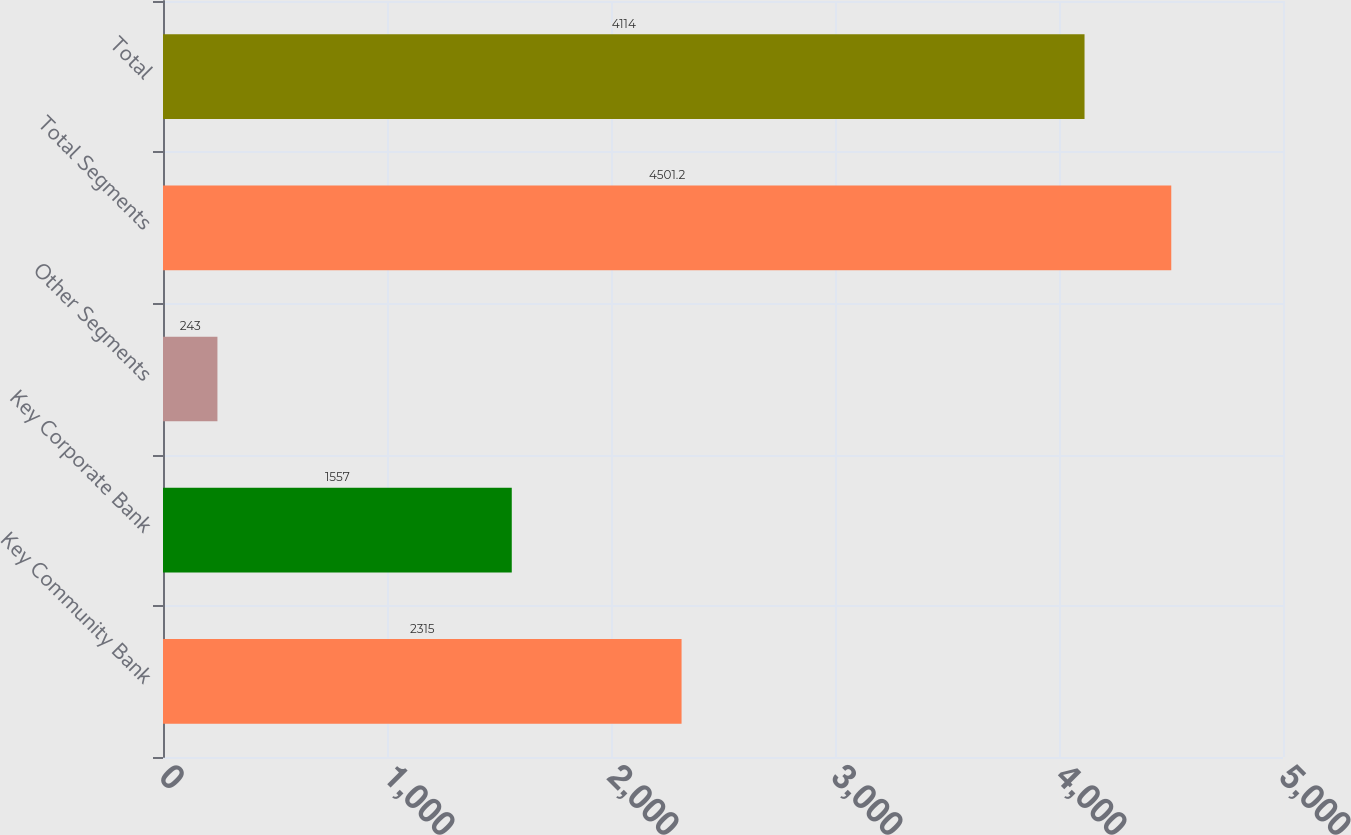Convert chart. <chart><loc_0><loc_0><loc_500><loc_500><bar_chart><fcel>Key Community Bank<fcel>Key Corporate Bank<fcel>Other Segments<fcel>Total Segments<fcel>Total<nl><fcel>2315<fcel>1557<fcel>243<fcel>4501.2<fcel>4114<nl></chart> 